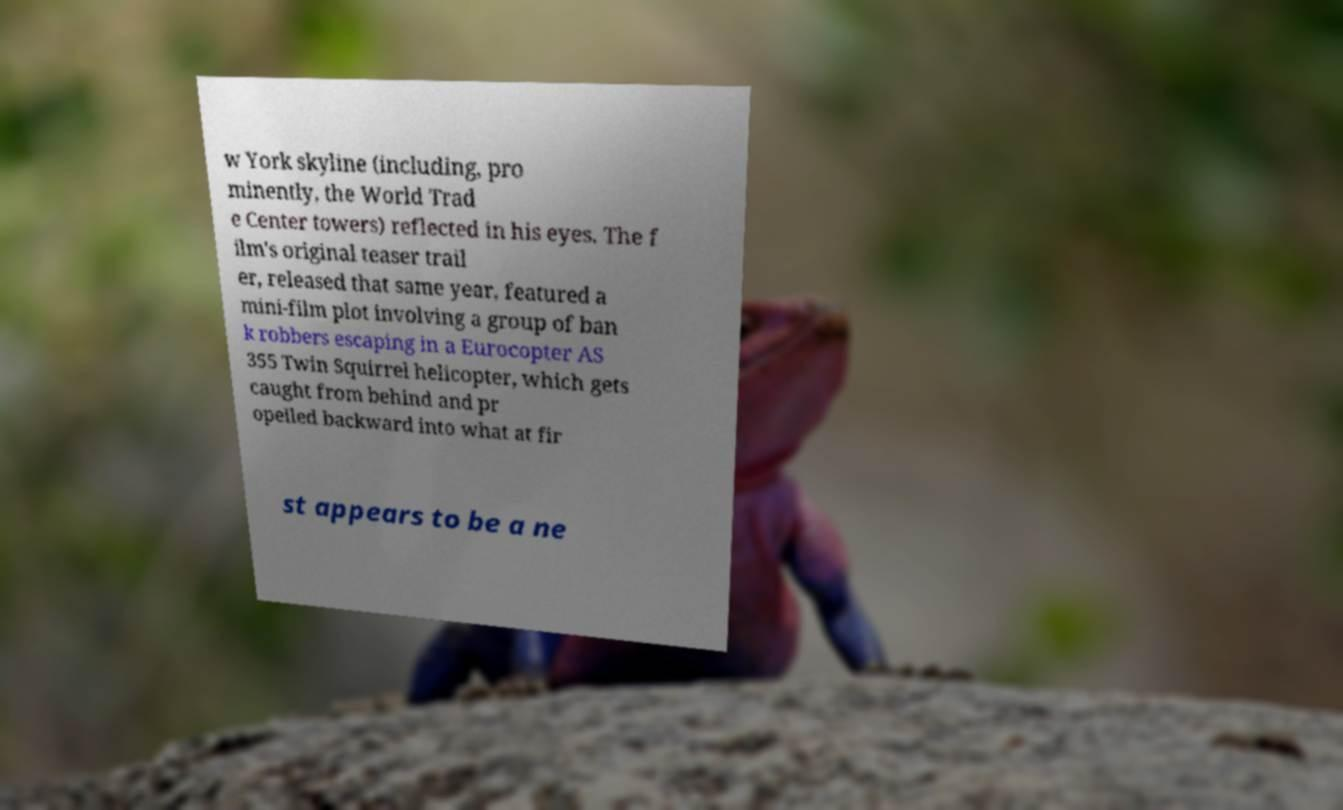I need the written content from this picture converted into text. Can you do that? w York skyline (including, pro minently, the World Trad e Center towers) reflected in his eyes. The f ilm's original teaser trail er, released that same year, featured a mini-film plot involving a group of ban k robbers escaping in a Eurocopter AS 355 Twin Squirrel helicopter, which gets caught from behind and pr opelled backward into what at fir st appears to be a ne 